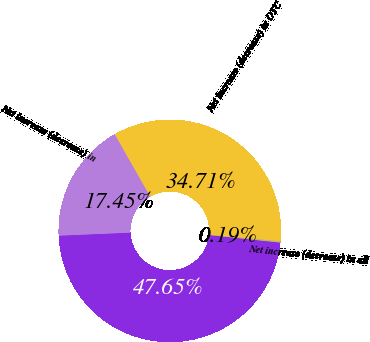<chart> <loc_0><loc_0><loc_500><loc_500><pie_chart><fcel>Total risk-weighted assets<fcel>Net increase (decrease) in<fcel>Net increase (decrease) in OTC<fcel>Net increase (decrease) in all<nl><fcel>47.65%<fcel>17.45%<fcel>34.71%<fcel>0.19%<nl></chart> 